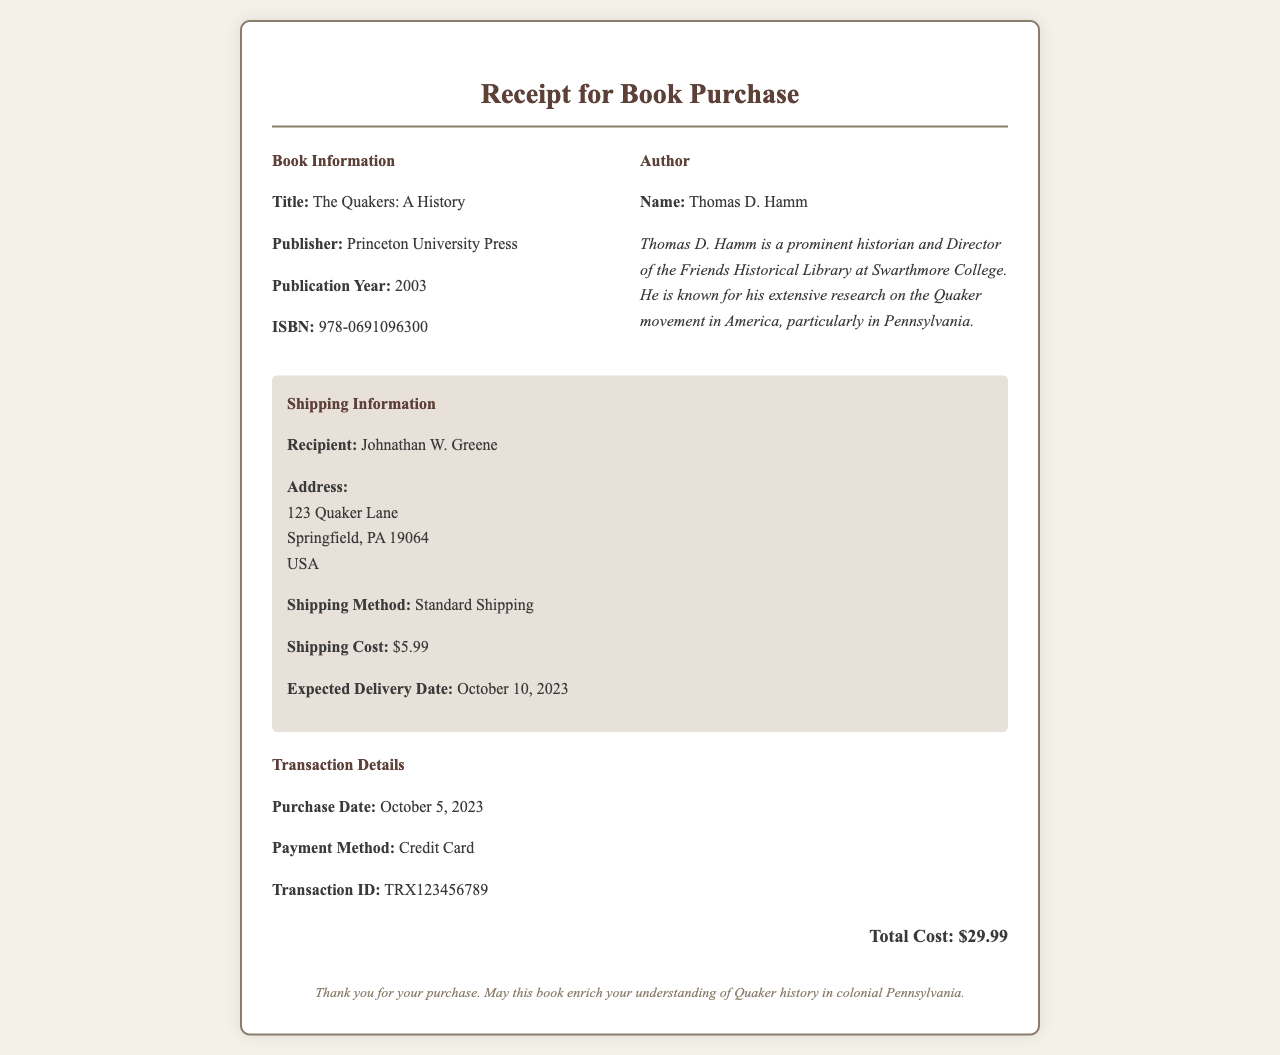What is the title of the book? The title of the book is specified in the document as "The Quakers: A History."
Answer: The Quakers: A History Who is the author of the book? The author's name is included in the author info section, which states "Thomas D. Hamm."
Answer: Thomas D. Hamm What is the publication year of the book? The publication year is mentioned in the book information as "2003."
Answer: 2003 What is the shipping cost? The document lists the shipping cost in the shipping information as "$5.99."
Answer: $5.99 What is the expected delivery date? The expected delivery date is provided in the shipping information section as "October 10, 2023."
Answer: October 10, 2023 What method was used for payment? The payment method is described in the transaction details section as "Credit Card."
Answer: Credit Card What is the total cost of the purchase? The total cost is summarized at the bottom of the receipt as "$29.99."
Answer: $29.99 Where is the recipient located? The recipient's address is detailed in the shipping information, specifically as "123 Quaker Lane, Springfield, PA 19064, USA."
Answer: 123 Quaker Lane, Springfield, PA 19064, USA What is the name of the publisher? The publisher's name is specified in the book information as "Princeton University Press."
Answer: Princeton University Press 